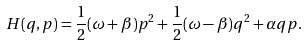<formula> <loc_0><loc_0><loc_500><loc_500>H ( q , p ) = \frac { 1 } { 2 } ( \omega + \beta ) p ^ { 2 } + \frac { 1 } { 2 } ( \omega - \beta ) q ^ { 2 } + \alpha q p .</formula> 